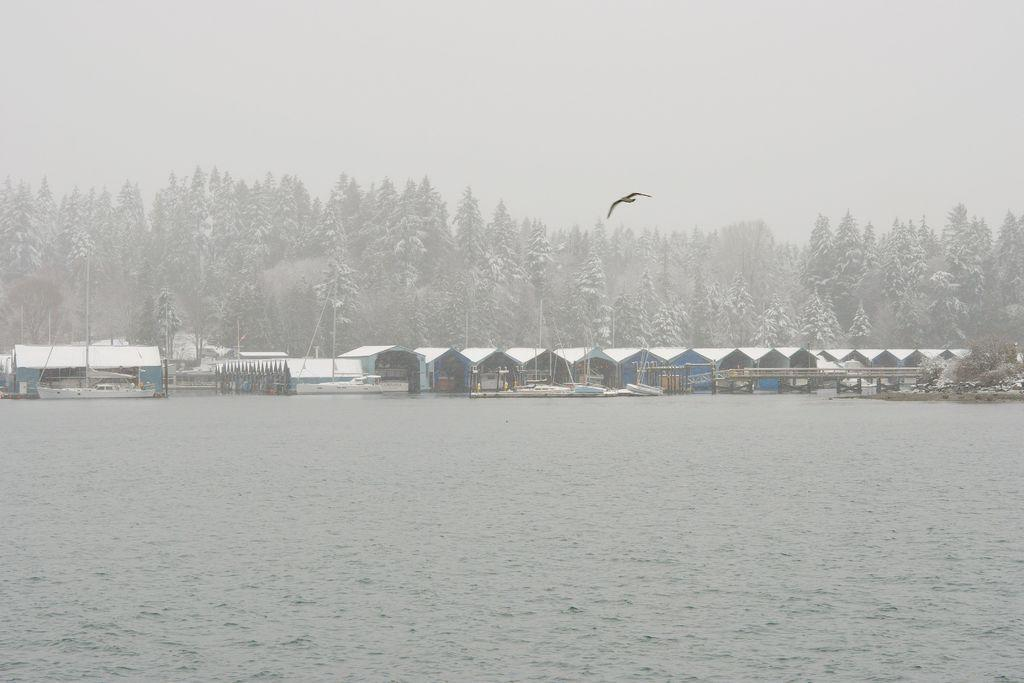What is the bird doing in the image? The bird is flying in the air in the image. What can be seen below the bird? There is water visible below the bird. What is in the background of the image? There are trees and objects covered with snow in the background of the image. Is there a person visible in the image holding a crayon? There is no person visible in the image holding a crayon; the image only features a bird flying in the air and its surroundings. 